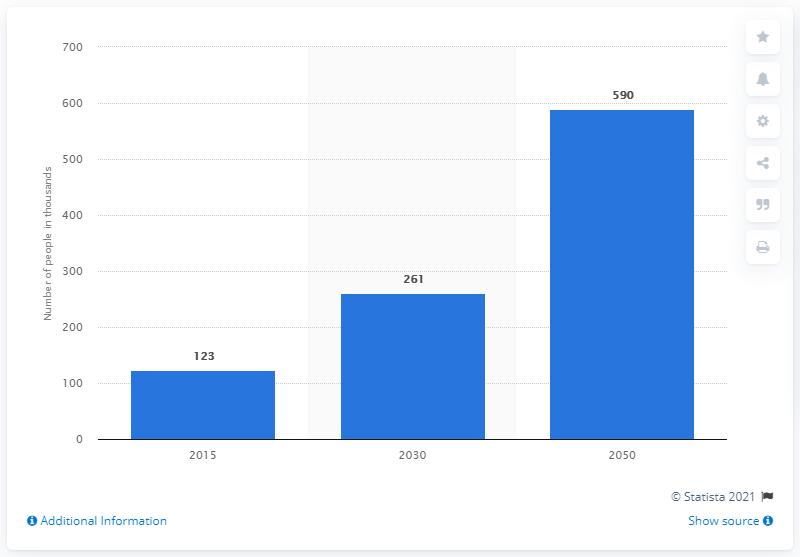Specify some key components in this picture. The number of people projected to have dementia by 2050 is expected to be approximately 590 million. 